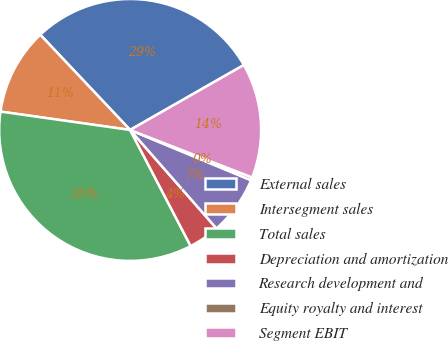Convert chart to OTSL. <chart><loc_0><loc_0><loc_500><loc_500><pie_chart><fcel>External sales<fcel>Intersegment sales<fcel>Total sales<fcel>Depreciation and amortization<fcel>Research development and<fcel>Equity royalty and interest<fcel>Segment EBIT<nl><fcel>28.78%<fcel>10.72%<fcel>34.89%<fcel>3.81%<fcel>7.27%<fcel>0.36%<fcel>14.17%<nl></chart> 